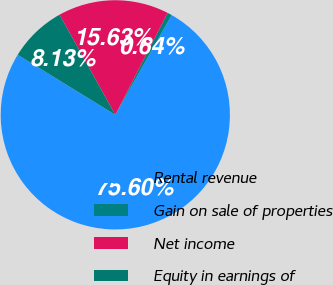Convert chart. <chart><loc_0><loc_0><loc_500><loc_500><pie_chart><fcel>Rental revenue<fcel>Gain on sale of properties<fcel>Net income<fcel>Equity in earnings of<nl><fcel>75.6%<fcel>0.64%<fcel>15.63%<fcel>8.13%<nl></chart> 